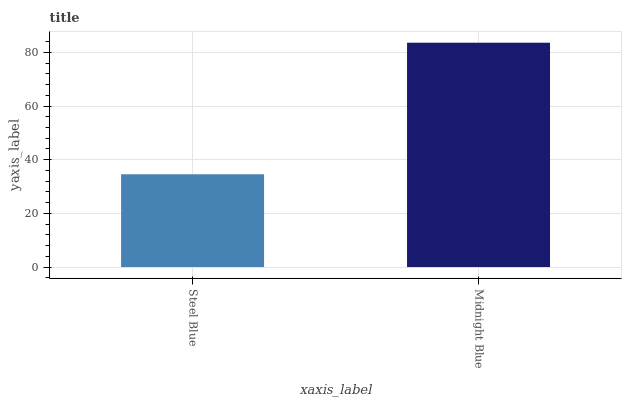Is Midnight Blue the minimum?
Answer yes or no. No. Is Midnight Blue greater than Steel Blue?
Answer yes or no. Yes. Is Steel Blue less than Midnight Blue?
Answer yes or no. Yes. Is Steel Blue greater than Midnight Blue?
Answer yes or no. No. Is Midnight Blue less than Steel Blue?
Answer yes or no. No. Is Midnight Blue the high median?
Answer yes or no. Yes. Is Steel Blue the low median?
Answer yes or no. Yes. Is Steel Blue the high median?
Answer yes or no. No. Is Midnight Blue the low median?
Answer yes or no. No. 